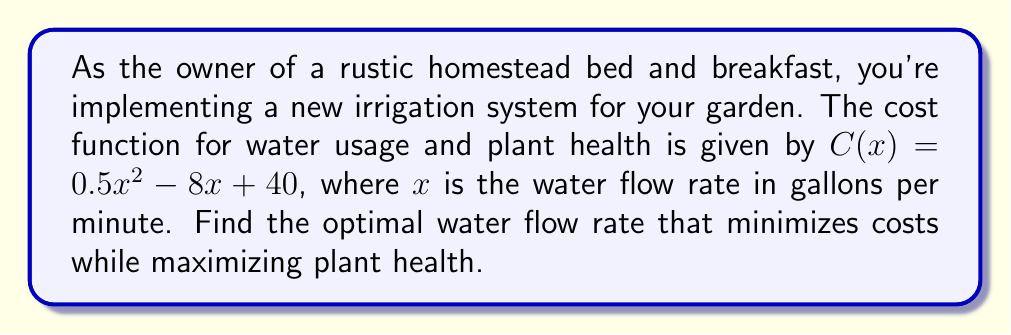Can you answer this question? To find the optimal water flow rate, we need to minimize the cost function $C(x)$. This occurs at the minimum point of the function, which can be found by setting the derivative equal to zero and solving for $x$.

Step 1: Find the derivative of the cost function.
$$C'(x) = \frac{d}{dx}(0.5x^2 - 8x + 40) = x - 8$$

Step 2: Set the derivative equal to zero and solve for $x$.
$$C'(x) = 0$$
$$x - 8 = 0$$
$$x = 8$$

Step 3: Verify that this is a minimum point by checking the second derivative.
$$C''(x) = \frac{d}{dx}(x - 8) = 1$$
Since $C''(x) > 0$, the critical point is a minimum.

Therefore, the optimal water flow rate is 8 gallons per minute, which minimizes costs and maximizes plant health for the irrigation system.
Answer: 8 gallons per minute 